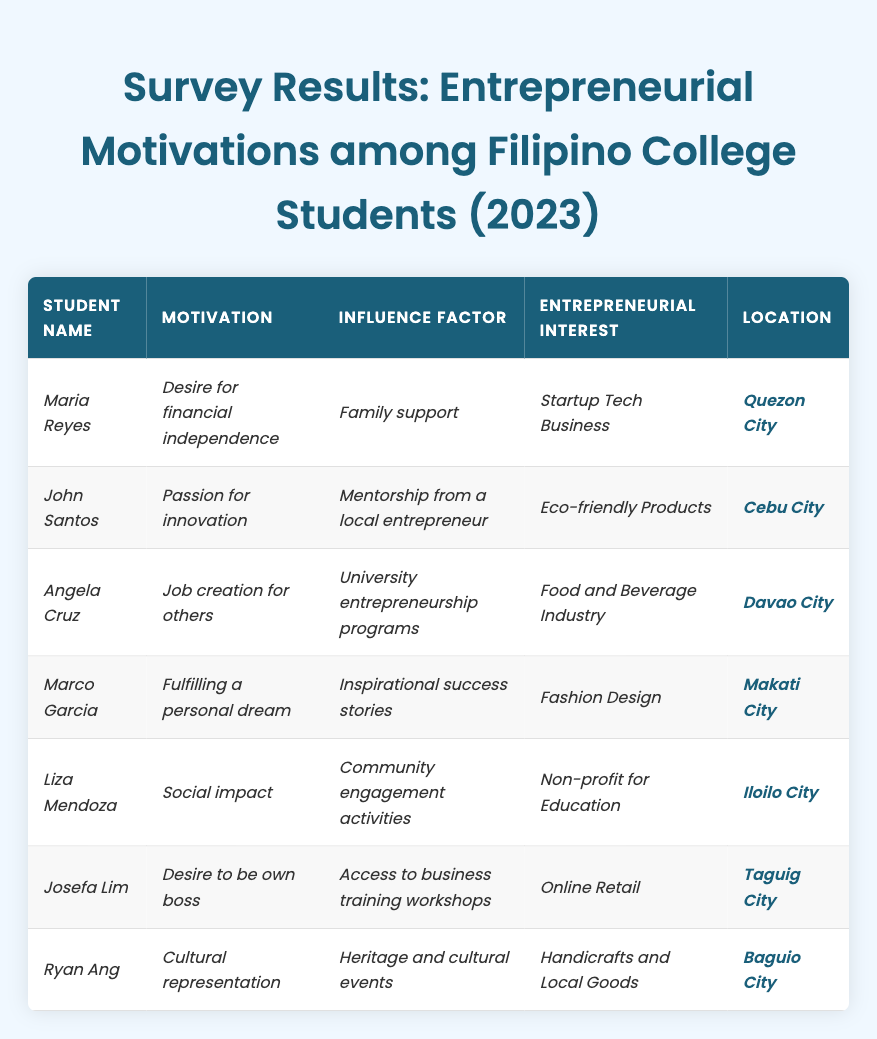What motivation does Angela Cruz have? In the table, Angela Cruz's row lists her motivation as "Job creation for others."
Answer: Job creation for others Which location has a student motivated by a desire for financial independence? Referring to the table, Maria Reyes, who is located in Quezon City, is motivated by the "Desire for financial independence."
Answer: Quezon City How many survey participants are interested in eco-friendly products? The table shows John Santos as the only student whose entrepreneurial interest is "Eco-friendly Products," thus there is only one participant interested in this area.
Answer: 1 Is there anyone in the survey who mentioned community engagement as their influence factor? Looking at the table, Liza Mendoza indicates "Community engagement activities" as her influence factor, so the answer is yes.
Answer: Yes What are the top two motivations found in the survey? By scanning the motivations listed in the table, the most common ones are "Desire to be own boss" (Josefa Lim) and "Social impact" (Liza Mendoza), making them the top two.
Answer: Desire to be own boss, Social impact Which entrepreneurial interest is associated with mentorship from a local entrepreneur? According to the table, John Santos has an entrepreneurial interest in "Eco-friendly Products," which he associates with the influence factor of "Mentorship from a local entrepreneur."
Answer: Eco-friendly Products How many students identified a personal fulfillment motivation? Only Marco Garcia lists "Fulfilling a personal dream" as a motivation, hence there is one student with this motivation.
Answer: 1 What are the influence factors mentioned by students from Quezon City and Davao City? Maria Reyes from Quezon City refers to "Family support" and Angela Cruz from Davao City mentions "University entrepreneurship programs" as their respective influence factors.
Answer: Family support, University entrepreneurship programs Which motivation is unique to the location of Baguio City? Ryan Ang from Baguio City mentions "Cultural representation" as his motivation, which is unique in this context since no other student shares this motivation.
Answer: Cultural representation Among the students, what percentage is motivated by the desire to make a social impact? There are 7 students total, and Liza Mendoza is the only one with "Social impact" as her motivation. Thus, the percentage is (1/7)*100 = approximately 14.29%.
Answer: ~14.29% 